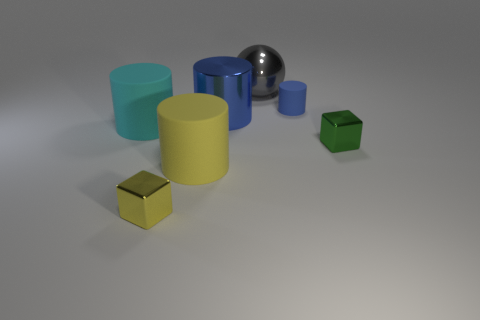There is a matte cylinder that is on the right side of the gray ball; is its color the same as the large thing behind the tiny cylinder?
Make the answer very short. No. There is a small blue object; are there any blue metal things right of it?
Provide a short and direct response. No. What color is the tiny object that is both in front of the large cyan cylinder and to the right of the gray ball?
Offer a very short reply. Green. Is there a shiny cube of the same color as the tiny cylinder?
Give a very brief answer. No. Is the small object that is on the left side of the gray thing made of the same material as the cylinder left of the yellow matte thing?
Your response must be concise. No. There is a metal thing right of the tiny blue matte thing; how big is it?
Provide a succinct answer. Small. What size is the yellow metal block?
Your answer should be compact. Small. There is a gray shiny sphere that is to the left of the tiny shiny block that is on the right side of the blue cylinder that is to the right of the gray metallic sphere; what size is it?
Keep it short and to the point. Large. Is there a big ball that has the same material as the large cyan cylinder?
Keep it short and to the point. No. What is the shape of the gray metal object?
Provide a short and direct response. Sphere. 